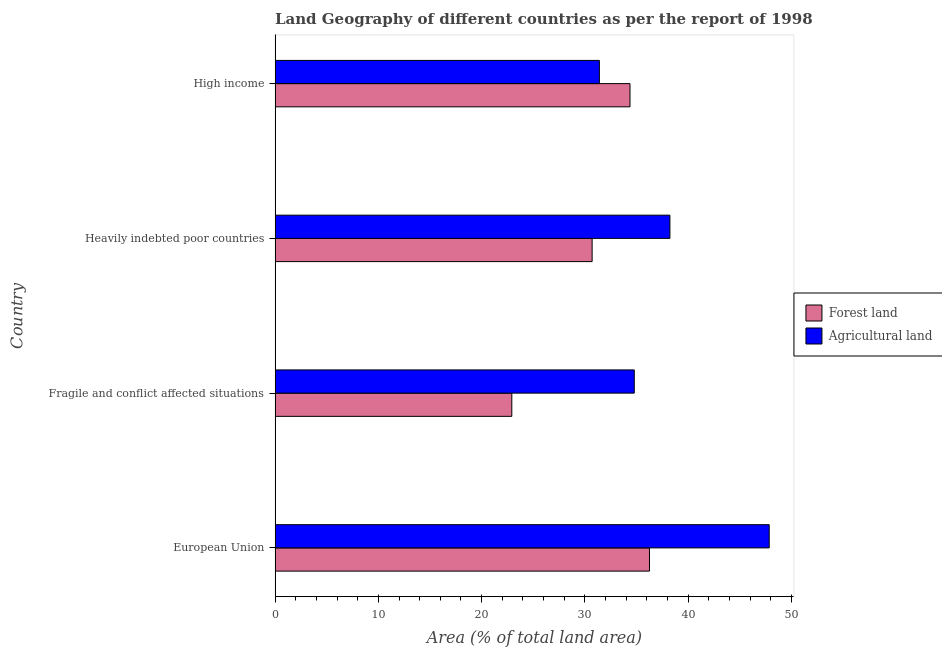How many different coloured bars are there?
Provide a short and direct response. 2. How many bars are there on the 2nd tick from the top?
Make the answer very short. 2. How many bars are there on the 2nd tick from the bottom?
Make the answer very short. 2. What is the label of the 3rd group of bars from the top?
Keep it short and to the point. Fragile and conflict affected situations. What is the percentage of land area under agriculture in High income?
Your answer should be very brief. 31.4. Across all countries, what is the maximum percentage of land area under agriculture?
Your response must be concise. 47.85. Across all countries, what is the minimum percentage of land area under agriculture?
Provide a succinct answer. 31.4. In which country was the percentage of land area under agriculture maximum?
Make the answer very short. European Union. What is the total percentage of land area under agriculture in the graph?
Your answer should be compact. 152.26. What is the difference between the percentage of land area under forests in Fragile and conflict affected situations and that in High income?
Offer a very short reply. -11.44. What is the difference between the percentage of land area under forests in Heavily indebted poor countries and the percentage of land area under agriculture in Fragile and conflict affected situations?
Your answer should be very brief. -4.08. What is the average percentage of land area under forests per country?
Make the answer very short. 31.06. What is the difference between the percentage of land area under forests and percentage of land area under agriculture in High income?
Your answer should be compact. 2.97. In how many countries, is the percentage of land area under forests greater than 16 %?
Offer a terse response. 4. What is the ratio of the percentage of land area under agriculture in European Union to that in High income?
Your response must be concise. 1.52. Is the difference between the percentage of land area under forests in Fragile and conflict affected situations and High income greater than the difference between the percentage of land area under agriculture in Fragile and conflict affected situations and High income?
Offer a terse response. No. What is the difference between the highest and the second highest percentage of land area under forests?
Your answer should be very brief. 1.89. What is the difference between the highest and the lowest percentage of land area under agriculture?
Keep it short and to the point. 16.45. What does the 1st bar from the top in European Union represents?
Provide a short and direct response. Agricultural land. What does the 2nd bar from the bottom in High income represents?
Give a very brief answer. Agricultural land. How many countries are there in the graph?
Keep it short and to the point. 4. Are the values on the major ticks of X-axis written in scientific E-notation?
Give a very brief answer. No. Where does the legend appear in the graph?
Make the answer very short. Center right. How many legend labels are there?
Offer a terse response. 2. What is the title of the graph?
Your response must be concise. Land Geography of different countries as per the report of 1998. Does "GDP per capita" appear as one of the legend labels in the graph?
Offer a very short reply. No. What is the label or title of the X-axis?
Give a very brief answer. Area (% of total land area). What is the label or title of the Y-axis?
Give a very brief answer. Country. What is the Area (% of total land area) in Forest land in European Union?
Give a very brief answer. 36.26. What is the Area (% of total land area) in Agricultural land in European Union?
Offer a terse response. 47.85. What is the Area (% of total land area) in Forest land in Fragile and conflict affected situations?
Make the answer very short. 22.92. What is the Area (% of total land area) of Agricultural land in Fragile and conflict affected situations?
Give a very brief answer. 34.78. What is the Area (% of total land area) of Forest land in Heavily indebted poor countries?
Your response must be concise. 30.7. What is the Area (% of total land area) in Agricultural land in Heavily indebted poor countries?
Offer a terse response. 38.23. What is the Area (% of total land area) of Forest land in High income?
Offer a terse response. 34.37. What is the Area (% of total land area) in Agricultural land in High income?
Your answer should be compact. 31.4. Across all countries, what is the maximum Area (% of total land area) in Forest land?
Your answer should be very brief. 36.26. Across all countries, what is the maximum Area (% of total land area) in Agricultural land?
Offer a very short reply. 47.85. Across all countries, what is the minimum Area (% of total land area) in Forest land?
Offer a terse response. 22.92. Across all countries, what is the minimum Area (% of total land area) in Agricultural land?
Your answer should be compact. 31.4. What is the total Area (% of total land area) of Forest land in the graph?
Your answer should be compact. 124.25. What is the total Area (% of total land area) in Agricultural land in the graph?
Offer a terse response. 152.26. What is the difference between the Area (% of total land area) in Forest land in European Union and that in Fragile and conflict affected situations?
Your answer should be very brief. 13.33. What is the difference between the Area (% of total land area) of Agricultural land in European Union and that in Fragile and conflict affected situations?
Offer a very short reply. 13.07. What is the difference between the Area (% of total land area) of Forest land in European Union and that in Heavily indebted poor countries?
Offer a terse response. 5.55. What is the difference between the Area (% of total land area) of Agricultural land in European Union and that in Heavily indebted poor countries?
Ensure brevity in your answer.  9.62. What is the difference between the Area (% of total land area) in Forest land in European Union and that in High income?
Give a very brief answer. 1.89. What is the difference between the Area (% of total land area) of Agricultural land in European Union and that in High income?
Provide a succinct answer. 16.45. What is the difference between the Area (% of total land area) of Forest land in Fragile and conflict affected situations and that in Heavily indebted poor countries?
Your response must be concise. -7.78. What is the difference between the Area (% of total land area) in Agricultural land in Fragile and conflict affected situations and that in Heavily indebted poor countries?
Offer a very short reply. -3.45. What is the difference between the Area (% of total land area) of Forest land in Fragile and conflict affected situations and that in High income?
Offer a very short reply. -11.44. What is the difference between the Area (% of total land area) of Agricultural land in Fragile and conflict affected situations and that in High income?
Your answer should be very brief. 3.38. What is the difference between the Area (% of total land area) of Forest land in Heavily indebted poor countries and that in High income?
Your answer should be very brief. -3.67. What is the difference between the Area (% of total land area) of Agricultural land in Heavily indebted poor countries and that in High income?
Make the answer very short. 6.83. What is the difference between the Area (% of total land area) of Forest land in European Union and the Area (% of total land area) of Agricultural land in Fragile and conflict affected situations?
Your answer should be very brief. 1.47. What is the difference between the Area (% of total land area) of Forest land in European Union and the Area (% of total land area) of Agricultural land in Heavily indebted poor countries?
Keep it short and to the point. -1.98. What is the difference between the Area (% of total land area) in Forest land in European Union and the Area (% of total land area) in Agricultural land in High income?
Ensure brevity in your answer.  4.85. What is the difference between the Area (% of total land area) of Forest land in Fragile and conflict affected situations and the Area (% of total land area) of Agricultural land in Heavily indebted poor countries?
Offer a very short reply. -15.31. What is the difference between the Area (% of total land area) in Forest land in Fragile and conflict affected situations and the Area (% of total land area) in Agricultural land in High income?
Provide a short and direct response. -8.48. What is the difference between the Area (% of total land area) of Forest land in Heavily indebted poor countries and the Area (% of total land area) of Agricultural land in High income?
Make the answer very short. -0.7. What is the average Area (% of total land area) in Forest land per country?
Provide a succinct answer. 31.06. What is the average Area (% of total land area) of Agricultural land per country?
Offer a terse response. 38.07. What is the difference between the Area (% of total land area) in Forest land and Area (% of total land area) in Agricultural land in European Union?
Your response must be concise. -11.59. What is the difference between the Area (% of total land area) in Forest land and Area (% of total land area) in Agricultural land in Fragile and conflict affected situations?
Ensure brevity in your answer.  -11.86. What is the difference between the Area (% of total land area) of Forest land and Area (% of total land area) of Agricultural land in Heavily indebted poor countries?
Give a very brief answer. -7.53. What is the difference between the Area (% of total land area) of Forest land and Area (% of total land area) of Agricultural land in High income?
Keep it short and to the point. 2.97. What is the ratio of the Area (% of total land area) in Forest land in European Union to that in Fragile and conflict affected situations?
Offer a very short reply. 1.58. What is the ratio of the Area (% of total land area) of Agricultural land in European Union to that in Fragile and conflict affected situations?
Your response must be concise. 1.38. What is the ratio of the Area (% of total land area) in Forest land in European Union to that in Heavily indebted poor countries?
Provide a short and direct response. 1.18. What is the ratio of the Area (% of total land area) of Agricultural land in European Union to that in Heavily indebted poor countries?
Offer a very short reply. 1.25. What is the ratio of the Area (% of total land area) of Forest land in European Union to that in High income?
Your response must be concise. 1.05. What is the ratio of the Area (% of total land area) of Agricultural land in European Union to that in High income?
Your answer should be compact. 1.52. What is the ratio of the Area (% of total land area) in Forest land in Fragile and conflict affected situations to that in Heavily indebted poor countries?
Your response must be concise. 0.75. What is the ratio of the Area (% of total land area) in Agricultural land in Fragile and conflict affected situations to that in Heavily indebted poor countries?
Make the answer very short. 0.91. What is the ratio of the Area (% of total land area) in Forest land in Fragile and conflict affected situations to that in High income?
Offer a terse response. 0.67. What is the ratio of the Area (% of total land area) of Agricultural land in Fragile and conflict affected situations to that in High income?
Keep it short and to the point. 1.11. What is the ratio of the Area (% of total land area) in Forest land in Heavily indebted poor countries to that in High income?
Provide a succinct answer. 0.89. What is the ratio of the Area (% of total land area) in Agricultural land in Heavily indebted poor countries to that in High income?
Ensure brevity in your answer.  1.22. What is the difference between the highest and the second highest Area (% of total land area) of Forest land?
Offer a very short reply. 1.89. What is the difference between the highest and the second highest Area (% of total land area) of Agricultural land?
Make the answer very short. 9.62. What is the difference between the highest and the lowest Area (% of total land area) in Forest land?
Ensure brevity in your answer.  13.33. What is the difference between the highest and the lowest Area (% of total land area) in Agricultural land?
Give a very brief answer. 16.45. 